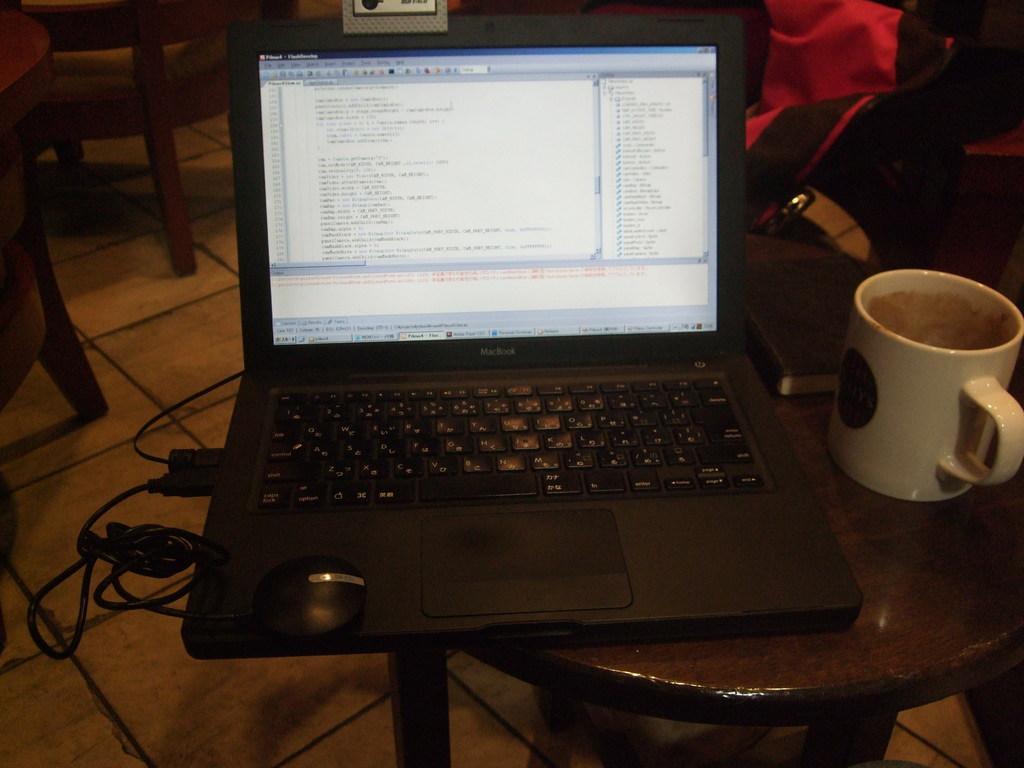How would you summarize this image in a sentence or two? In the given picture there is a laptop on the table, with some wires connected to it. Beside the laptop there is a cup. In the background there is a bag. 